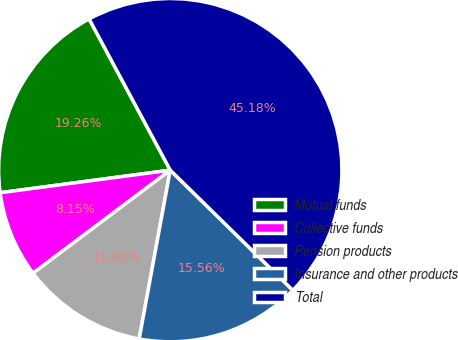Convert chart to OTSL. <chart><loc_0><loc_0><loc_500><loc_500><pie_chart><fcel>Mutual funds<fcel>Collective funds<fcel>Pension products<fcel>Insurance and other products<fcel>Total<nl><fcel>19.26%<fcel>8.15%<fcel>11.85%<fcel>15.56%<fcel>45.18%<nl></chart> 